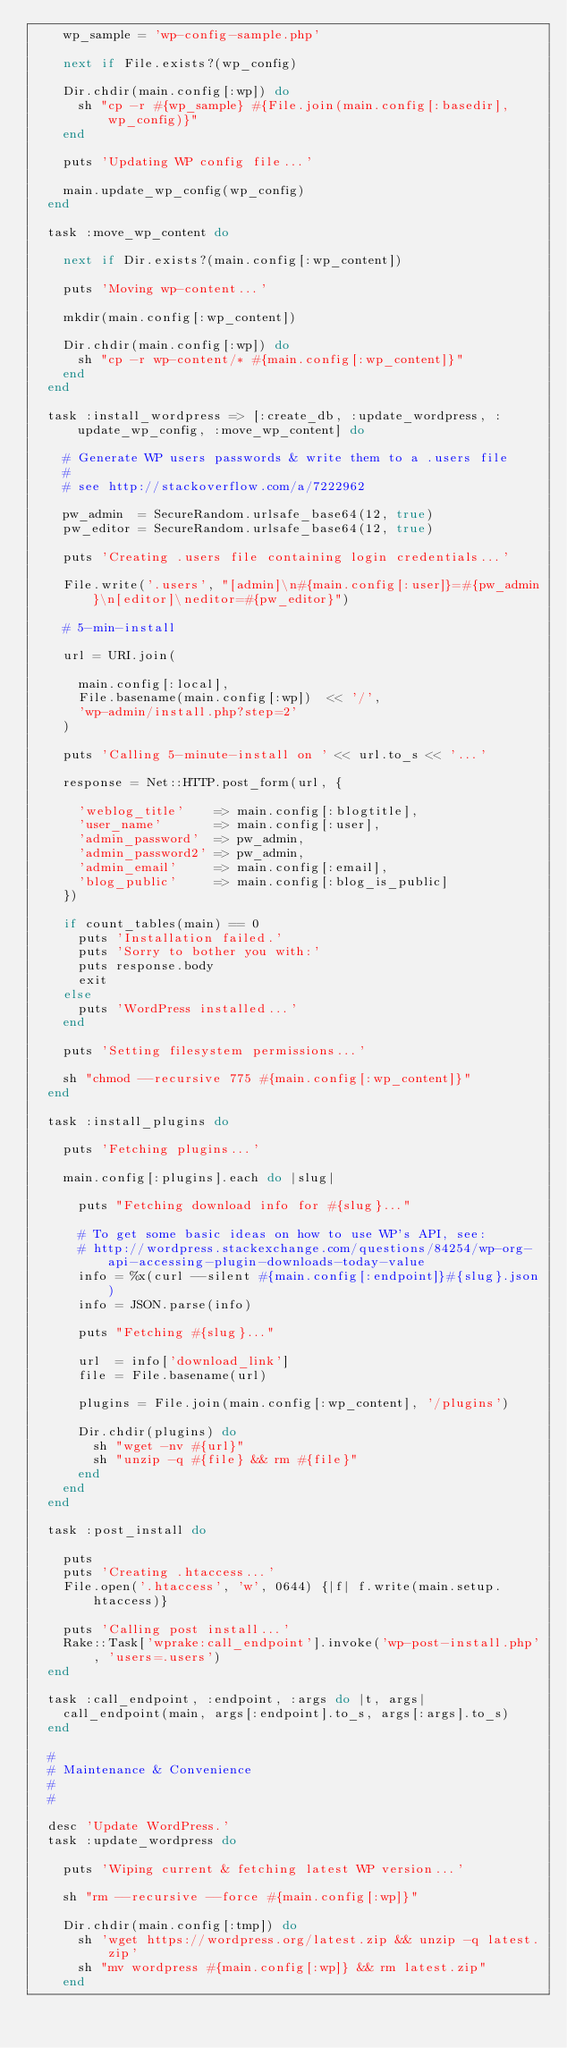Convert code to text. <code><loc_0><loc_0><loc_500><loc_500><_Ruby_>    wp_sample = 'wp-config-sample.php'

    next if File.exists?(wp_config)

    Dir.chdir(main.config[:wp]) do
      sh "cp -r #{wp_sample} #{File.join(main.config[:basedir], wp_config)}"
    end

    puts 'Updating WP config file...'

    main.update_wp_config(wp_config)
  end

  task :move_wp_content do

    next if Dir.exists?(main.config[:wp_content])

    puts 'Moving wp-content...'

    mkdir(main.config[:wp_content])

    Dir.chdir(main.config[:wp]) do
      sh "cp -r wp-content/* #{main.config[:wp_content]}"
    end
  end

  task :install_wordpress => [:create_db, :update_wordpress, :update_wp_config, :move_wp_content] do

    # Generate WP users passwords & write them to a .users file
    #
    # see http://stackoverflow.com/a/7222962

    pw_admin  = SecureRandom.urlsafe_base64(12, true)
    pw_editor = SecureRandom.urlsafe_base64(12, true)

    puts 'Creating .users file containing login credentials...'

    File.write('.users', "[admin]\n#{main.config[:user]}=#{pw_admin}\n[editor]\neditor=#{pw_editor}")

    # 5-min-install

    url = URI.join(

      main.config[:local],
      File.basename(main.config[:wp])  << '/',
      'wp-admin/install.php?step=2'
    )

    puts 'Calling 5-minute-install on ' << url.to_s << '...'

    response = Net::HTTP.post_form(url, {

      'weblog_title'    => main.config[:blogtitle],
      'user_name'       => main.config[:user],
      'admin_password'  => pw_admin,
      'admin_password2' => pw_admin,
      'admin_email'     => main.config[:email],
      'blog_public'     => main.config[:blog_is_public]
    })

    if count_tables(main) == 0
      puts 'Installation failed.'
      puts 'Sorry to bother you with:'
      puts response.body
      exit
    else
      puts 'WordPress installed...'
    end

    puts 'Setting filesystem permissions...'

    sh "chmod --recursive 775 #{main.config[:wp_content]}"
  end

  task :install_plugins do

    puts 'Fetching plugins...'

    main.config[:plugins].each do |slug|

      puts "Fetching download info for #{slug}..."

      # To get some basic ideas on how to use WP's API, see:
      # http://wordpress.stackexchange.com/questions/84254/wp-org-api-accessing-plugin-downloads-today-value
      info = %x(curl --silent #{main.config[:endpoint]}#{slug}.json)
      info = JSON.parse(info)

      puts "Fetching #{slug}..."

      url  = info['download_link']
      file = File.basename(url)

      plugins = File.join(main.config[:wp_content], '/plugins')

      Dir.chdir(plugins) do
        sh "wget -nv #{url}"
        sh "unzip -q #{file} && rm #{file}"
      end
    end
  end

  task :post_install do

    puts
    puts 'Creating .htaccess...'
    File.open('.htaccess', 'w', 0644) {|f| f.write(main.setup.htaccess)}

    puts 'Calling post install...'
    Rake::Task['wprake:call_endpoint'].invoke('wp-post-install.php', 'users=.users')
  end

  task :call_endpoint, :endpoint, :args do |t, args|
    call_endpoint(main, args[:endpoint].to_s, args[:args].to_s)
  end

  #
  # Maintenance & Convenience
  #
  #

  desc 'Update WordPress.'
  task :update_wordpress do

    puts 'Wiping current & fetching latest WP version...'

    sh "rm --recursive --force #{main.config[:wp]}"

    Dir.chdir(main.config[:tmp]) do
      sh 'wget https://wordpress.org/latest.zip && unzip -q latest.zip'
      sh "mv wordpress #{main.config[:wp]} && rm latest.zip"
    end
</code> 